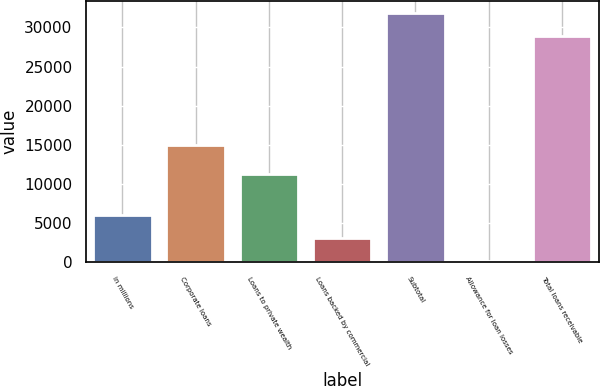Convert chart to OTSL. <chart><loc_0><loc_0><loc_500><loc_500><bar_chart><fcel>in millions<fcel>Corporate loans<fcel>Loans to private wealth<fcel>Loans backed by commercial<fcel>Subtotal<fcel>Allowance for loan losses<fcel>Total loans receivable<nl><fcel>6015.6<fcel>15044<fcel>11289<fcel>3121.8<fcel>31831.8<fcel>228<fcel>28938<nl></chart> 